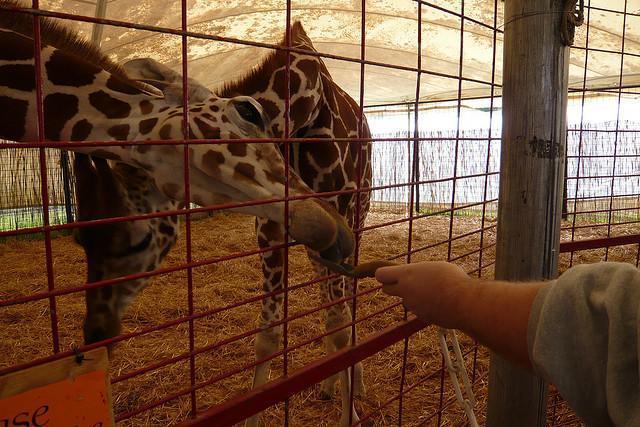How many giraffe are there?
Give a very brief answer. 2. How many giraffes are there?
Give a very brief answer. 2. How many trains are there?
Give a very brief answer. 0. 